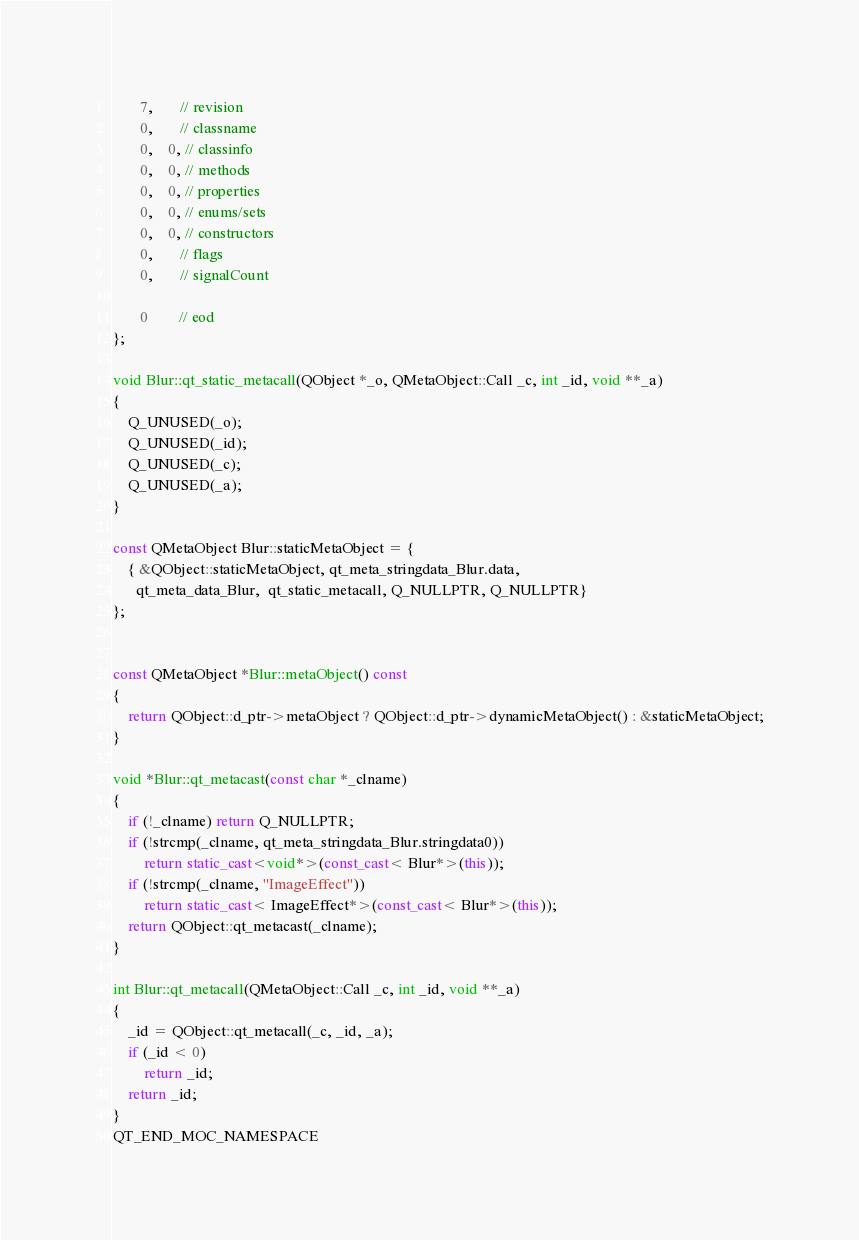Convert code to text. <code><loc_0><loc_0><loc_500><loc_500><_C++_>       7,       // revision
       0,       // classname
       0,    0, // classinfo
       0,    0, // methods
       0,    0, // properties
       0,    0, // enums/sets
       0,    0, // constructors
       0,       // flags
       0,       // signalCount

       0        // eod
};

void Blur::qt_static_metacall(QObject *_o, QMetaObject::Call _c, int _id, void **_a)
{
    Q_UNUSED(_o);
    Q_UNUSED(_id);
    Q_UNUSED(_c);
    Q_UNUSED(_a);
}

const QMetaObject Blur::staticMetaObject = {
    { &QObject::staticMetaObject, qt_meta_stringdata_Blur.data,
      qt_meta_data_Blur,  qt_static_metacall, Q_NULLPTR, Q_NULLPTR}
};


const QMetaObject *Blur::metaObject() const
{
    return QObject::d_ptr->metaObject ? QObject::d_ptr->dynamicMetaObject() : &staticMetaObject;
}

void *Blur::qt_metacast(const char *_clname)
{
    if (!_clname) return Q_NULLPTR;
    if (!strcmp(_clname, qt_meta_stringdata_Blur.stringdata0))
        return static_cast<void*>(const_cast< Blur*>(this));
    if (!strcmp(_clname, "ImageEffect"))
        return static_cast< ImageEffect*>(const_cast< Blur*>(this));
    return QObject::qt_metacast(_clname);
}

int Blur::qt_metacall(QMetaObject::Call _c, int _id, void **_a)
{
    _id = QObject::qt_metacall(_c, _id, _a);
    if (_id < 0)
        return _id;
    return _id;
}
QT_END_MOC_NAMESPACE
</code> 